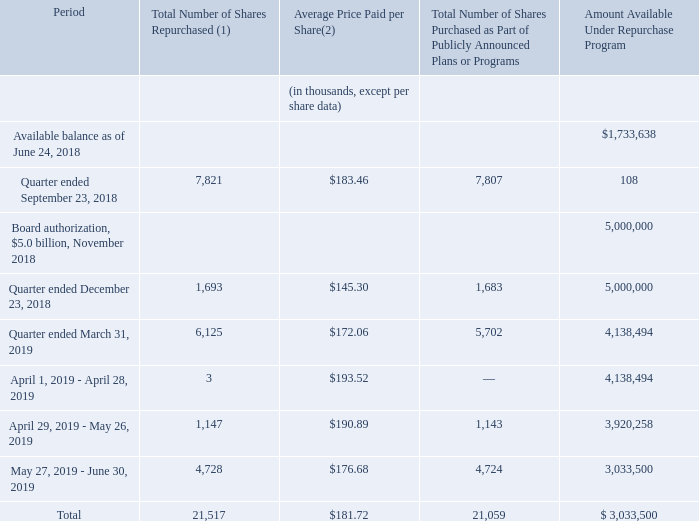Repurchase of Company Shares
In November 2018, the Board of Directors authorized management to repurchase up to an additional $5.0 billion of Common Stock on such terms and conditions as it deems appropriate. These repurchases can be conducted on the open market or as private purchases and may include the use of derivative contracts with large financial institutions, in all cases subject to compliance with applicable law. This repurchase program has no termination date and may be suspended or discontinued at any time. Funding for this share repurchase program may be through a combination of cash on hand, cash generation, and borrowings. As of June 30, 2019, we have purchased approximately $2.0 billion of shares under this authorization, $0.5 billion via open market trading and $1.5 billion utilizing accelerated share repurchase arrangements.
Accelerated Share Repurchase Agreements
On June 4, 2019, we entered into four separate accelerated share repurchase agreements (collectively, the “June 2019 ASR”) with two financial institutions to repurchase a total of $750 million of Common Stock. We took an initial delivery of approximately 3.1 million shares, which represented 75% of the prepayment amount divided by our closing stock price on June 4, 2019. The total number of shares received under the June 2019 ASR will be based upon the average daily volume weighted average price of our Common Stock during the repurchase period, less an agreed upon discount. Final settlement of the June 2019 ASR is anticipated to occur no later than November 20, 2019.
On January 31, 2019, we entered into two separate accelerated share repurchase agreements (collectively, the “January 2019 ASR”) with two financial institutions to repurchase a total of $760 million of Common Stock. We took an initial delivery of approximately 3.3 million shares, which represented 75% of the prepayment amount divided by our closing stock price on January 30, 2019. The total number of shares received under the January 2019 ASR was based upon the average daily volume weighted average price of our Common Stock during the repurchase period, less an agreed upon discount. Final settlement of the agreements occurred during May 2019, resulted in the receipt of approximately 0.8 million additional shares, which yielded a weighted-average share price of approximately $182.32 for the transaction period.
Share repurchases, including those under the repurchase program, were as follows:
(1) During the fiscal year ended June 30, 2019, we acquired 0.5 million shares at a total cost of $80.5 million which we withheld through net share settlements to cover minimum tax withholding obligations upon the vesting of restricted stock unit awards granted under our equity compensation plans. The shares retained by us through these net share settlements are not a part of the Board-authorized repurchase program but instead are authorized under our equity compensation plan.
(2) Average price paid per share excludes effect of accelerated share repurchases, see additional disclosure above regarding our accelerated share repurchase activity during the fiscal year.
What is the total number of shares repurchased?
Answer scale should be: thousand. 21,517. What was the total cost of the shares that were withheld during the fiscal year ended June 30, 2019? $80.5 million. What will the total number of shares received under the June 2019 ASR will be based upon? The average daily volume weighted average price of our common stock during the repurchase period, less an agreed upon discount. What is the percentage of shares repurchased in Quarter ended December 23, 2018 in the total repurchased shares?
Answer scale should be: percent. 1,693/21,517
Answer: 7.87. What is the percentage of shares repurchased within May 27, 2019 - June 30, 2019 in the total repurchased shares?
Answer scale should be: percent. 4,728/21,517
Answer: 21.97. What is the percentage of the Total Number of Shares Purchased as Part of Publicly Announced Plans or Programs in the Total Number of Shares Repurchased?
Answer scale should be: percent. 21,059/21,517
Answer: 97.87. 